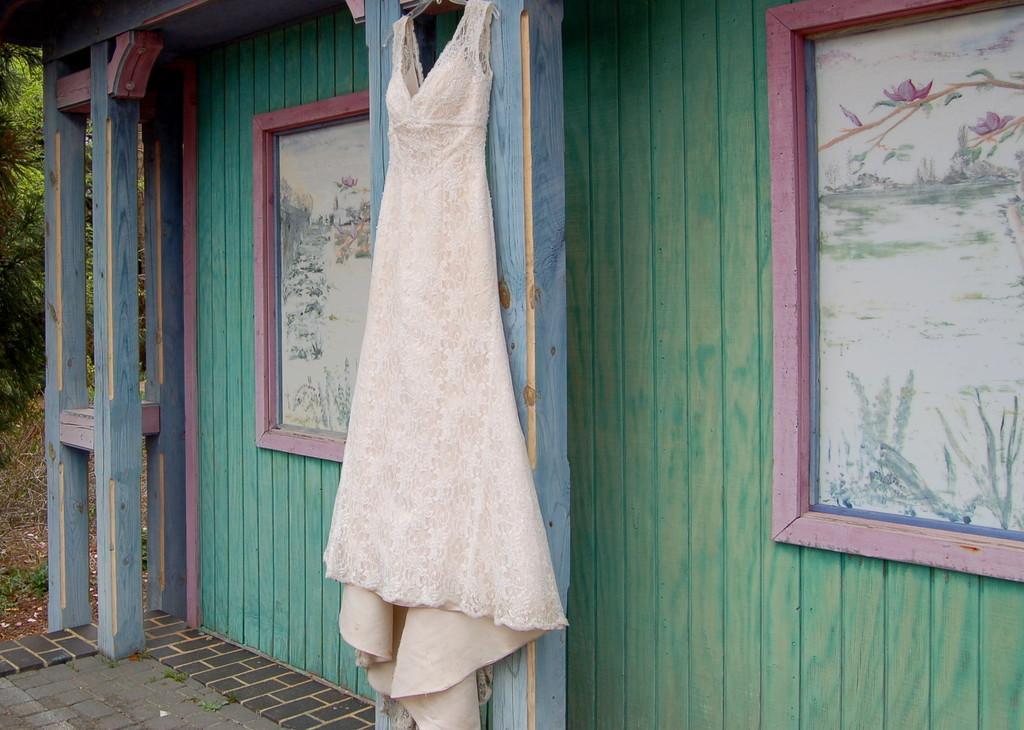In one or two sentences, can you explain what this image depicts? In this image we can see a frock with a hanger. We can also see the wall and also windows with the painting. At the bottom we can see the land. We can also see the trees on the left. 